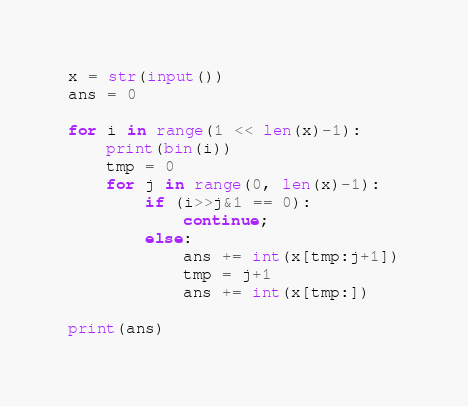Convert code to text. <code><loc_0><loc_0><loc_500><loc_500><_Python_>x = str(input())
ans = 0

for i in range(1 << len(x)-1):
    print(bin(i))
    tmp = 0
    for j in range(0, len(x)-1):
        if (i>>j&1 == 0):
            continue;
        else:
            ans += int(x[tmp:j+1])
            tmp = j+1
            ans += int(x[tmp:])

print(ans)</code> 